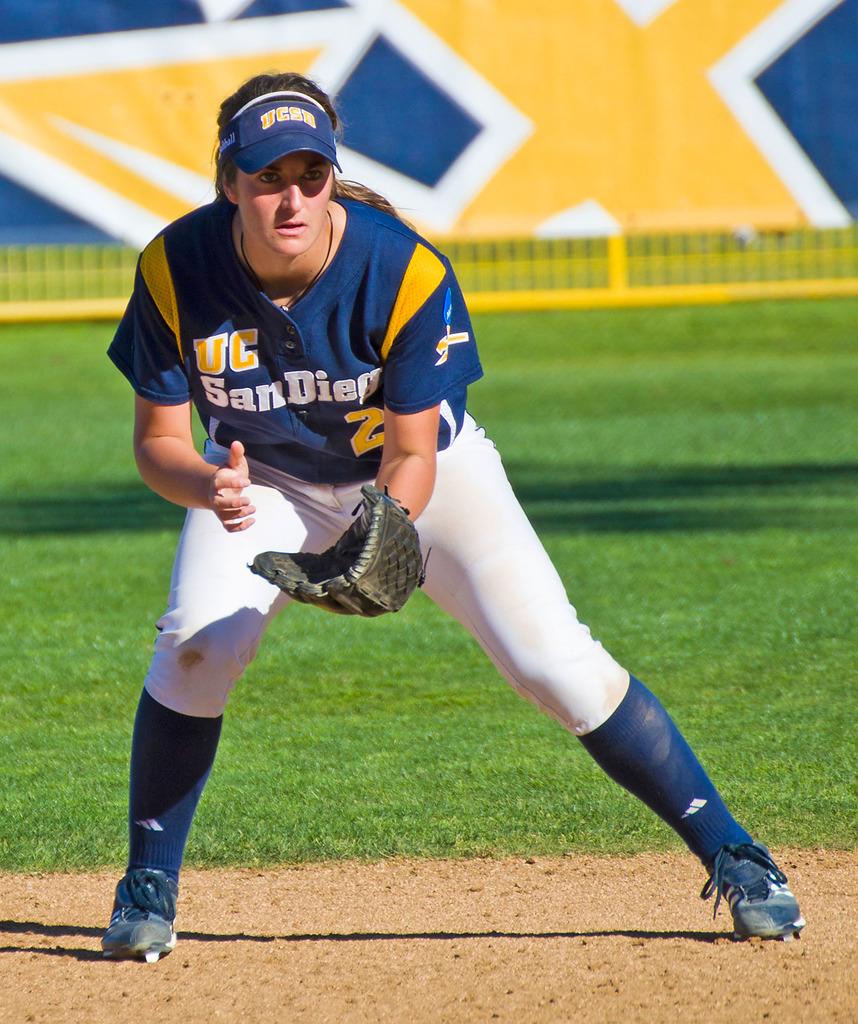What team is on the woman's jersey?
Provide a succinct answer. San diego. What initials form the logo on this woman's visor?
Ensure brevity in your answer.  Ucsd. 